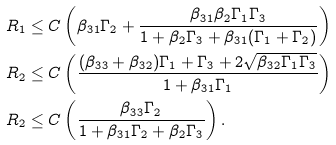Convert formula to latex. <formula><loc_0><loc_0><loc_500><loc_500>R _ { 1 } & \leq C \left ( \beta _ { 3 1 } \Gamma _ { 2 } + \frac { \beta _ { 3 1 } \beta _ { 2 } \Gamma _ { 1 } \Gamma _ { 3 } } { 1 + \beta _ { 2 } \Gamma _ { 3 } + \beta _ { 3 1 } ( \Gamma _ { 1 } + \Gamma _ { 2 } ) } \right ) \\ R _ { 2 } & \leq C \left ( \frac { ( \beta _ { 3 3 } + \beta _ { 3 2 } ) \Gamma _ { 1 } + \Gamma _ { 3 } + 2 \sqrt { \beta _ { 3 2 } \Gamma _ { 1 } \Gamma _ { 3 } } } { 1 + \beta _ { 3 1 } \Gamma _ { 1 } } \right ) \\ R _ { 2 } & \leq C \left ( \frac { \beta _ { 3 3 } \Gamma _ { 2 } } { 1 + \beta _ { 3 1 } \Gamma _ { 2 } + \beta _ { 2 } \Gamma _ { 3 } } \right ) .</formula> 